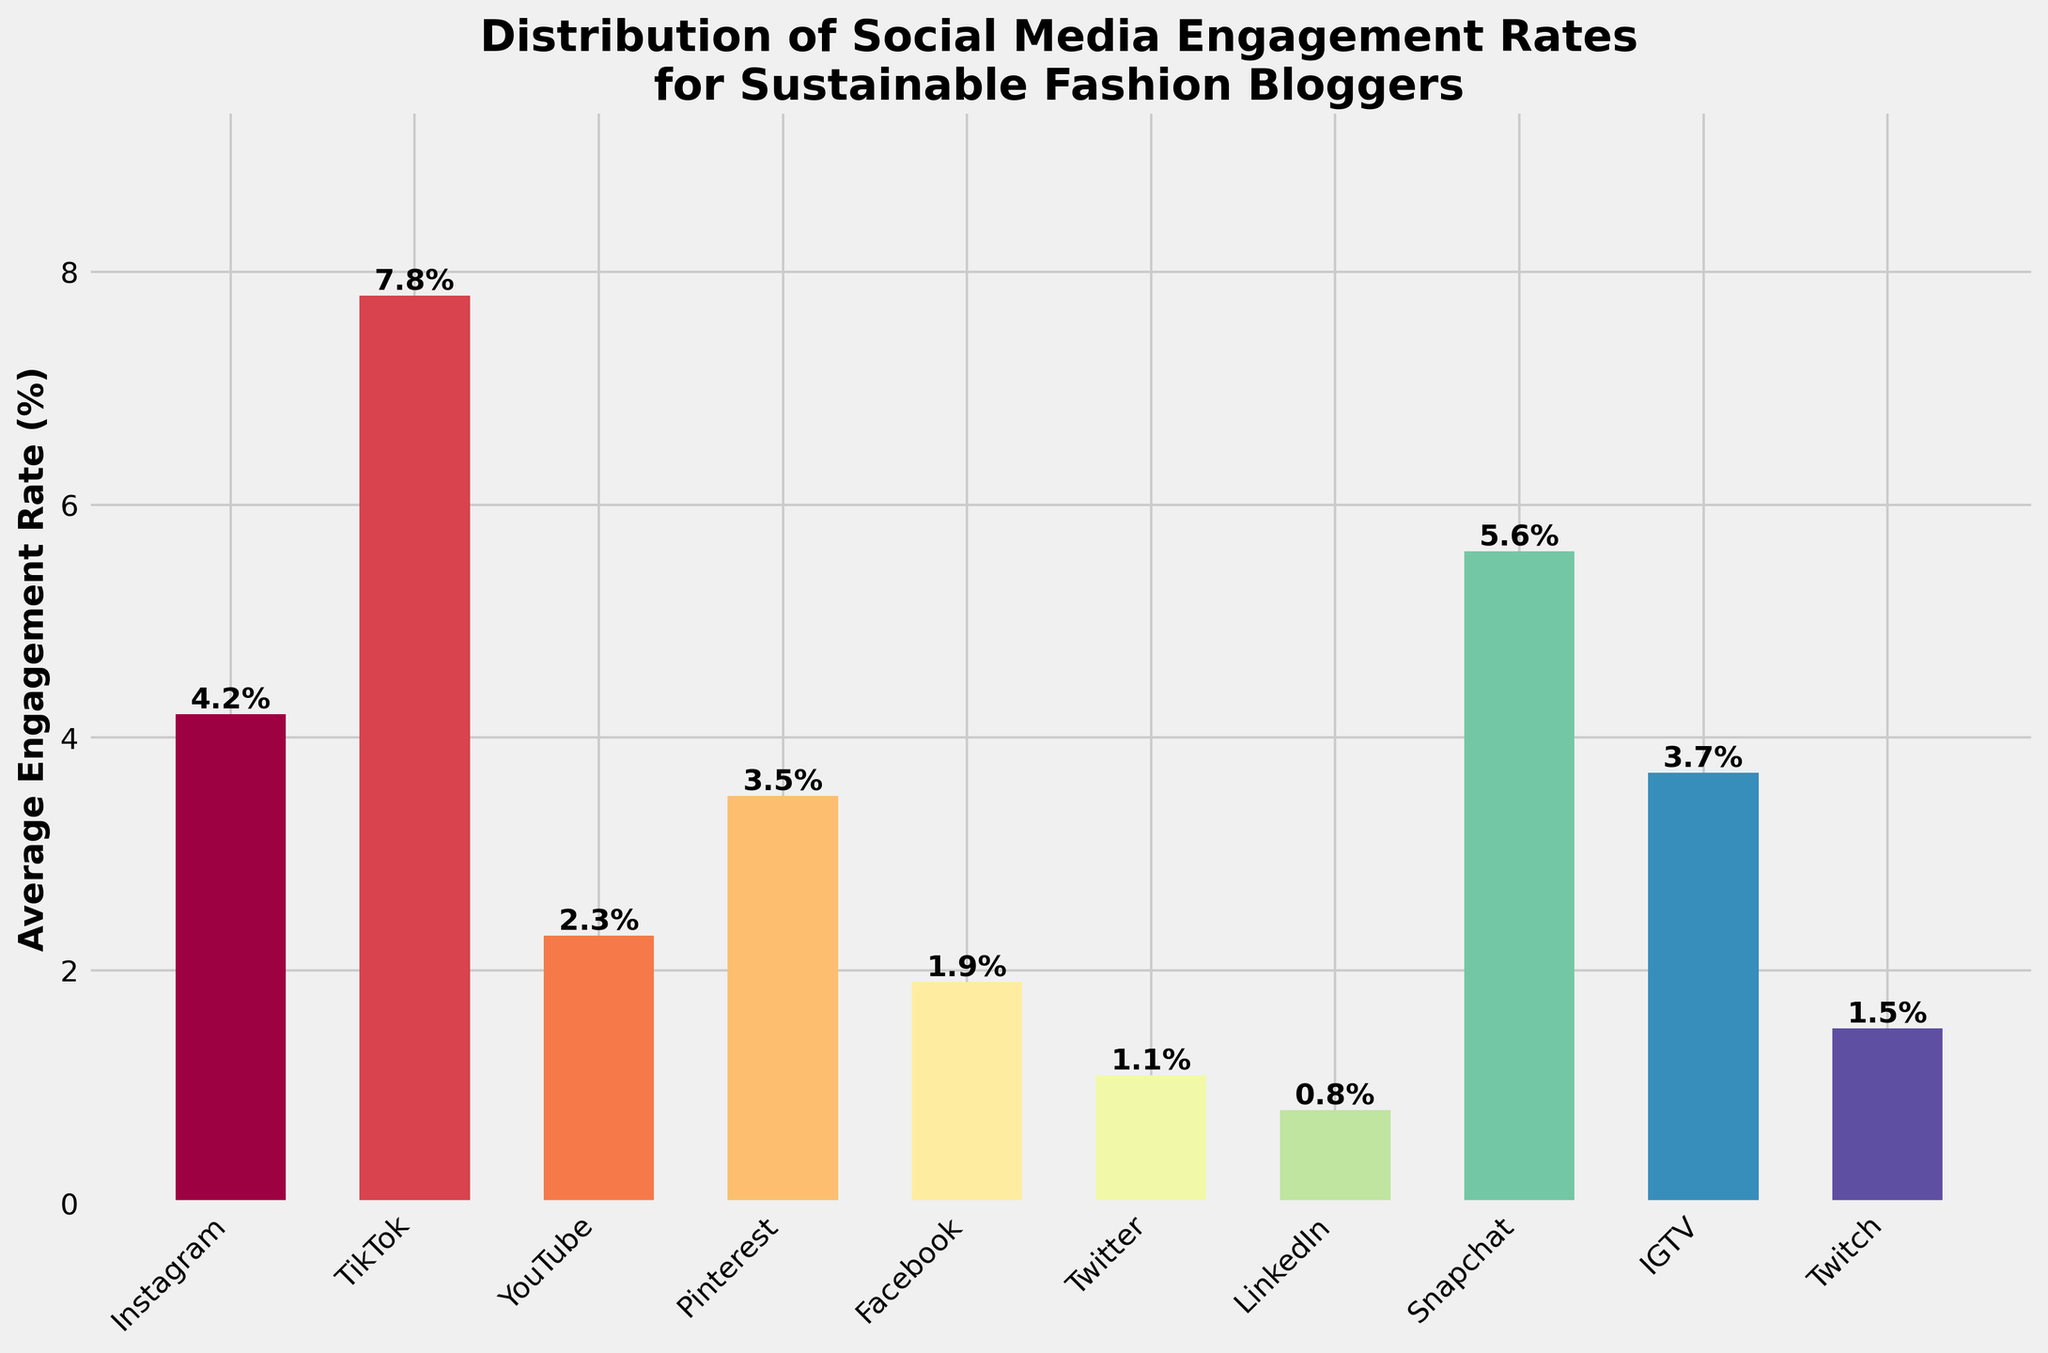How would you rank the platforms based on their average engagement rate? First, list the platforms by their engagement rates: Instagram 4.2%, TikTok 7.8%, YouTube 2.3%, etc. Then, order them from highest to lowest engagement rates.
Answer: 1. TikTok, 2. Snapchat, 3. IGTV, 4. Instagram, 5. Pinterest, 6. YouTube, 7. Twitch, 8. Facebook, 9. Twitter, 10. LinkedIn Which platform has the lowest average engagement rate? Look at the bars in the chart and identify the shortest one, which represents the platform with the lowest average engagement rate.
Answer: LinkedIn What is the total average engagement rate if you combine Instagram and YouTube? Sum their engagement rates: Instagram (4.2%) + YouTube (2.3%).
Answer: 6.5% Which platform has a higher engagement rate, Pinterest or Twitter, and by how much? Compare the heights of the bars for Pinterest and Twitter. Subtract Twitter's engagement rate (1.1%) from Pinterest's (3.5%).
Answer: Pinterest by 2.4% Which three platforms have engagement rates closest to 4%? Identify the platforms with engagement rates around 4%: Instagram (4.2%), Pinterest (3.5%), IGTV (3.7%).
Answer: Instagram, Pinterest, IGTV What is the average engagement rate for Instagram, Snapchat, and TikTok? Sum their rates: Instagram (4.2%), Snapchat (5.6%), TikTok (7.8%) and then divide by 3 (number of platforms).
Answer: 5.87% Which platform has a marginally better engagement rate: IGTV or Pinterest? Compare the heights of the bars for IGTV (3.7%) and Pinterest (3.5%).
Answer: IGTV How much higher is TikTok's engagement rate compared to LinkedIn's? Subtract the shorter engagement rate (LinkedIn's 0.8%) from the higher one (TikTok's 7.8%).
Answer: 7.0% If you combine the engagement rates of Facebook and Twitch, how does it compare to YouTube's rate? Sum Facebook's rate (1.9%) and Twitch's (1.5%) and then compare this combined rate to YouTube's (2.3%). 1.9% + 1.5% = 3.4%, and 3.4% is greater than 2.3%.
Answer: Combined rate is higher Which platforms have an engagement rate below the average of all platforms? Calculate the average engagement rate for all platforms, then identify platforms below this average rate. Sum the rates: (4.2 + 7.8 + 2.3 + 3.5 + 1.9 + 1.1 + 0.8 + 5.6 + 3.7 + 1.5)/10 = 3.24%. Platforms below 3.24%: YouTube, Facebook, Twitter, LinkedIn, Twitch.
Answer: YouTube, Facebook, Twitter, LinkedIn, Twitch 